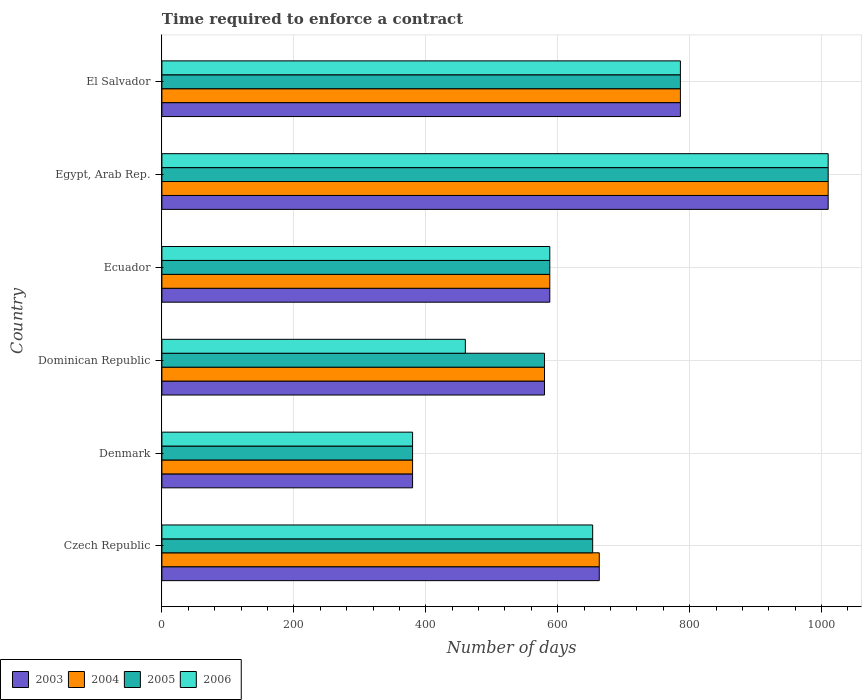Are the number of bars per tick equal to the number of legend labels?
Make the answer very short. Yes. What is the label of the 5th group of bars from the top?
Keep it short and to the point. Denmark. What is the number of days required to enforce a contract in 2005 in Dominican Republic?
Your answer should be very brief. 580. Across all countries, what is the maximum number of days required to enforce a contract in 2004?
Ensure brevity in your answer.  1010. Across all countries, what is the minimum number of days required to enforce a contract in 2006?
Your response must be concise. 380. In which country was the number of days required to enforce a contract in 2003 maximum?
Ensure brevity in your answer.  Egypt, Arab Rep. In which country was the number of days required to enforce a contract in 2004 minimum?
Make the answer very short. Denmark. What is the total number of days required to enforce a contract in 2005 in the graph?
Your response must be concise. 3997. What is the difference between the number of days required to enforce a contract in 2004 in Denmark and that in Egypt, Arab Rep.?
Give a very brief answer. -630. What is the difference between the number of days required to enforce a contract in 2006 in Dominican Republic and the number of days required to enforce a contract in 2005 in El Salvador?
Offer a very short reply. -326. What is the average number of days required to enforce a contract in 2004 per country?
Ensure brevity in your answer.  667.83. In how many countries, is the number of days required to enforce a contract in 2006 greater than 520 days?
Ensure brevity in your answer.  4. What is the ratio of the number of days required to enforce a contract in 2003 in Denmark to that in Egypt, Arab Rep.?
Ensure brevity in your answer.  0.38. Is the difference between the number of days required to enforce a contract in 2006 in Czech Republic and Egypt, Arab Rep. greater than the difference between the number of days required to enforce a contract in 2005 in Czech Republic and Egypt, Arab Rep.?
Keep it short and to the point. No. What is the difference between the highest and the second highest number of days required to enforce a contract in 2004?
Give a very brief answer. 224. What is the difference between the highest and the lowest number of days required to enforce a contract in 2004?
Provide a short and direct response. 630. Is it the case that in every country, the sum of the number of days required to enforce a contract in 2004 and number of days required to enforce a contract in 2005 is greater than the sum of number of days required to enforce a contract in 2006 and number of days required to enforce a contract in 2003?
Ensure brevity in your answer.  No. What does the 1st bar from the top in Dominican Republic represents?
Keep it short and to the point. 2006. What does the 1st bar from the bottom in El Salvador represents?
Offer a terse response. 2003. Are all the bars in the graph horizontal?
Give a very brief answer. Yes. What is the difference between two consecutive major ticks on the X-axis?
Your answer should be compact. 200. Are the values on the major ticks of X-axis written in scientific E-notation?
Your answer should be very brief. No. What is the title of the graph?
Your response must be concise. Time required to enforce a contract. What is the label or title of the X-axis?
Your response must be concise. Number of days. What is the Number of days in 2003 in Czech Republic?
Ensure brevity in your answer.  663. What is the Number of days of 2004 in Czech Republic?
Provide a succinct answer. 663. What is the Number of days in 2005 in Czech Republic?
Provide a short and direct response. 653. What is the Number of days in 2006 in Czech Republic?
Ensure brevity in your answer.  653. What is the Number of days of 2003 in Denmark?
Your answer should be very brief. 380. What is the Number of days of 2004 in Denmark?
Your response must be concise. 380. What is the Number of days of 2005 in Denmark?
Your answer should be compact. 380. What is the Number of days of 2006 in Denmark?
Keep it short and to the point. 380. What is the Number of days in 2003 in Dominican Republic?
Provide a succinct answer. 580. What is the Number of days in 2004 in Dominican Republic?
Keep it short and to the point. 580. What is the Number of days of 2005 in Dominican Republic?
Make the answer very short. 580. What is the Number of days in 2006 in Dominican Republic?
Ensure brevity in your answer.  460. What is the Number of days of 2003 in Ecuador?
Your answer should be very brief. 588. What is the Number of days of 2004 in Ecuador?
Your answer should be very brief. 588. What is the Number of days in 2005 in Ecuador?
Make the answer very short. 588. What is the Number of days in 2006 in Ecuador?
Make the answer very short. 588. What is the Number of days in 2003 in Egypt, Arab Rep.?
Make the answer very short. 1010. What is the Number of days in 2004 in Egypt, Arab Rep.?
Give a very brief answer. 1010. What is the Number of days of 2005 in Egypt, Arab Rep.?
Your response must be concise. 1010. What is the Number of days of 2006 in Egypt, Arab Rep.?
Offer a terse response. 1010. What is the Number of days of 2003 in El Salvador?
Provide a succinct answer. 786. What is the Number of days of 2004 in El Salvador?
Make the answer very short. 786. What is the Number of days in 2005 in El Salvador?
Your response must be concise. 786. What is the Number of days in 2006 in El Salvador?
Your response must be concise. 786. Across all countries, what is the maximum Number of days in 2003?
Give a very brief answer. 1010. Across all countries, what is the maximum Number of days of 2004?
Ensure brevity in your answer.  1010. Across all countries, what is the maximum Number of days in 2005?
Provide a short and direct response. 1010. Across all countries, what is the maximum Number of days of 2006?
Give a very brief answer. 1010. Across all countries, what is the minimum Number of days in 2003?
Give a very brief answer. 380. Across all countries, what is the minimum Number of days of 2004?
Ensure brevity in your answer.  380. Across all countries, what is the minimum Number of days of 2005?
Provide a succinct answer. 380. Across all countries, what is the minimum Number of days in 2006?
Provide a short and direct response. 380. What is the total Number of days of 2003 in the graph?
Your answer should be very brief. 4007. What is the total Number of days of 2004 in the graph?
Your answer should be compact. 4007. What is the total Number of days in 2005 in the graph?
Make the answer very short. 3997. What is the total Number of days of 2006 in the graph?
Offer a terse response. 3877. What is the difference between the Number of days of 2003 in Czech Republic and that in Denmark?
Provide a succinct answer. 283. What is the difference between the Number of days of 2004 in Czech Republic and that in Denmark?
Offer a terse response. 283. What is the difference between the Number of days of 2005 in Czech Republic and that in Denmark?
Your answer should be very brief. 273. What is the difference between the Number of days in 2006 in Czech Republic and that in Denmark?
Make the answer very short. 273. What is the difference between the Number of days of 2004 in Czech Republic and that in Dominican Republic?
Your response must be concise. 83. What is the difference between the Number of days in 2006 in Czech Republic and that in Dominican Republic?
Provide a short and direct response. 193. What is the difference between the Number of days of 2003 in Czech Republic and that in Egypt, Arab Rep.?
Give a very brief answer. -347. What is the difference between the Number of days in 2004 in Czech Republic and that in Egypt, Arab Rep.?
Your answer should be compact. -347. What is the difference between the Number of days in 2005 in Czech Republic and that in Egypt, Arab Rep.?
Your response must be concise. -357. What is the difference between the Number of days of 2006 in Czech Republic and that in Egypt, Arab Rep.?
Ensure brevity in your answer.  -357. What is the difference between the Number of days of 2003 in Czech Republic and that in El Salvador?
Give a very brief answer. -123. What is the difference between the Number of days of 2004 in Czech Republic and that in El Salvador?
Your answer should be very brief. -123. What is the difference between the Number of days of 2005 in Czech Republic and that in El Salvador?
Your answer should be compact. -133. What is the difference between the Number of days in 2006 in Czech Republic and that in El Salvador?
Keep it short and to the point. -133. What is the difference between the Number of days in 2003 in Denmark and that in Dominican Republic?
Give a very brief answer. -200. What is the difference between the Number of days in 2004 in Denmark and that in Dominican Republic?
Your response must be concise. -200. What is the difference between the Number of days of 2005 in Denmark and that in Dominican Republic?
Your response must be concise. -200. What is the difference between the Number of days of 2006 in Denmark and that in Dominican Republic?
Your answer should be very brief. -80. What is the difference between the Number of days of 2003 in Denmark and that in Ecuador?
Offer a very short reply. -208. What is the difference between the Number of days of 2004 in Denmark and that in Ecuador?
Offer a very short reply. -208. What is the difference between the Number of days in 2005 in Denmark and that in Ecuador?
Ensure brevity in your answer.  -208. What is the difference between the Number of days in 2006 in Denmark and that in Ecuador?
Provide a short and direct response. -208. What is the difference between the Number of days in 2003 in Denmark and that in Egypt, Arab Rep.?
Give a very brief answer. -630. What is the difference between the Number of days of 2004 in Denmark and that in Egypt, Arab Rep.?
Your answer should be very brief. -630. What is the difference between the Number of days of 2005 in Denmark and that in Egypt, Arab Rep.?
Provide a succinct answer. -630. What is the difference between the Number of days in 2006 in Denmark and that in Egypt, Arab Rep.?
Make the answer very short. -630. What is the difference between the Number of days of 2003 in Denmark and that in El Salvador?
Your response must be concise. -406. What is the difference between the Number of days in 2004 in Denmark and that in El Salvador?
Make the answer very short. -406. What is the difference between the Number of days in 2005 in Denmark and that in El Salvador?
Ensure brevity in your answer.  -406. What is the difference between the Number of days in 2006 in Denmark and that in El Salvador?
Offer a very short reply. -406. What is the difference between the Number of days of 2003 in Dominican Republic and that in Ecuador?
Your answer should be compact. -8. What is the difference between the Number of days of 2006 in Dominican Republic and that in Ecuador?
Offer a very short reply. -128. What is the difference between the Number of days of 2003 in Dominican Republic and that in Egypt, Arab Rep.?
Your answer should be very brief. -430. What is the difference between the Number of days in 2004 in Dominican Republic and that in Egypt, Arab Rep.?
Give a very brief answer. -430. What is the difference between the Number of days in 2005 in Dominican Republic and that in Egypt, Arab Rep.?
Provide a short and direct response. -430. What is the difference between the Number of days in 2006 in Dominican Republic and that in Egypt, Arab Rep.?
Keep it short and to the point. -550. What is the difference between the Number of days of 2003 in Dominican Republic and that in El Salvador?
Provide a short and direct response. -206. What is the difference between the Number of days in 2004 in Dominican Republic and that in El Salvador?
Your answer should be compact. -206. What is the difference between the Number of days in 2005 in Dominican Republic and that in El Salvador?
Your response must be concise. -206. What is the difference between the Number of days of 2006 in Dominican Republic and that in El Salvador?
Your response must be concise. -326. What is the difference between the Number of days in 2003 in Ecuador and that in Egypt, Arab Rep.?
Offer a terse response. -422. What is the difference between the Number of days in 2004 in Ecuador and that in Egypt, Arab Rep.?
Your response must be concise. -422. What is the difference between the Number of days in 2005 in Ecuador and that in Egypt, Arab Rep.?
Your answer should be very brief. -422. What is the difference between the Number of days of 2006 in Ecuador and that in Egypt, Arab Rep.?
Provide a succinct answer. -422. What is the difference between the Number of days of 2003 in Ecuador and that in El Salvador?
Ensure brevity in your answer.  -198. What is the difference between the Number of days in 2004 in Ecuador and that in El Salvador?
Keep it short and to the point. -198. What is the difference between the Number of days of 2005 in Ecuador and that in El Salvador?
Give a very brief answer. -198. What is the difference between the Number of days in 2006 in Ecuador and that in El Salvador?
Provide a succinct answer. -198. What is the difference between the Number of days of 2003 in Egypt, Arab Rep. and that in El Salvador?
Offer a terse response. 224. What is the difference between the Number of days in 2004 in Egypt, Arab Rep. and that in El Salvador?
Ensure brevity in your answer.  224. What is the difference between the Number of days of 2005 in Egypt, Arab Rep. and that in El Salvador?
Keep it short and to the point. 224. What is the difference between the Number of days of 2006 in Egypt, Arab Rep. and that in El Salvador?
Provide a short and direct response. 224. What is the difference between the Number of days of 2003 in Czech Republic and the Number of days of 2004 in Denmark?
Provide a short and direct response. 283. What is the difference between the Number of days in 2003 in Czech Republic and the Number of days in 2005 in Denmark?
Make the answer very short. 283. What is the difference between the Number of days of 2003 in Czech Republic and the Number of days of 2006 in Denmark?
Keep it short and to the point. 283. What is the difference between the Number of days in 2004 in Czech Republic and the Number of days in 2005 in Denmark?
Make the answer very short. 283. What is the difference between the Number of days of 2004 in Czech Republic and the Number of days of 2006 in Denmark?
Your response must be concise. 283. What is the difference between the Number of days in 2005 in Czech Republic and the Number of days in 2006 in Denmark?
Your response must be concise. 273. What is the difference between the Number of days of 2003 in Czech Republic and the Number of days of 2004 in Dominican Republic?
Give a very brief answer. 83. What is the difference between the Number of days in 2003 in Czech Republic and the Number of days in 2006 in Dominican Republic?
Offer a very short reply. 203. What is the difference between the Number of days of 2004 in Czech Republic and the Number of days of 2006 in Dominican Republic?
Offer a terse response. 203. What is the difference between the Number of days in 2005 in Czech Republic and the Number of days in 2006 in Dominican Republic?
Give a very brief answer. 193. What is the difference between the Number of days in 2003 in Czech Republic and the Number of days in 2004 in Ecuador?
Ensure brevity in your answer.  75. What is the difference between the Number of days of 2003 in Czech Republic and the Number of days of 2006 in Ecuador?
Make the answer very short. 75. What is the difference between the Number of days in 2005 in Czech Republic and the Number of days in 2006 in Ecuador?
Provide a succinct answer. 65. What is the difference between the Number of days of 2003 in Czech Republic and the Number of days of 2004 in Egypt, Arab Rep.?
Offer a terse response. -347. What is the difference between the Number of days in 2003 in Czech Republic and the Number of days in 2005 in Egypt, Arab Rep.?
Provide a short and direct response. -347. What is the difference between the Number of days in 2003 in Czech Republic and the Number of days in 2006 in Egypt, Arab Rep.?
Provide a succinct answer. -347. What is the difference between the Number of days of 2004 in Czech Republic and the Number of days of 2005 in Egypt, Arab Rep.?
Keep it short and to the point. -347. What is the difference between the Number of days of 2004 in Czech Republic and the Number of days of 2006 in Egypt, Arab Rep.?
Keep it short and to the point. -347. What is the difference between the Number of days of 2005 in Czech Republic and the Number of days of 2006 in Egypt, Arab Rep.?
Offer a very short reply. -357. What is the difference between the Number of days of 2003 in Czech Republic and the Number of days of 2004 in El Salvador?
Your answer should be compact. -123. What is the difference between the Number of days in 2003 in Czech Republic and the Number of days in 2005 in El Salvador?
Your answer should be very brief. -123. What is the difference between the Number of days of 2003 in Czech Republic and the Number of days of 2006 in El Salvador?
Ensure brevity in your answer.  -123. What is the difference between the Number of days of 2004 in Czech Republic and the Number of days of 2005 in El Salvador?
Provide a short and direct response. -123. What is the difference between the Number of days of 2004 in Czech Republic and the Number of days of 2006 in El Salvador?
Make the answer very short. -123. What is the difference between the Number of days in 2005 in Czech Republic and the Number of days in 2006 in El Salvador?
Provide a succinct answer. -133. What is the difference between the Number of days of 2003 in Denmark and the Number of days of 2004 in Dominican Republic?
Make the answer very short. -200. What is the difference between the Number of days in 2003 in Denmark and the Number of days in 2005 in Dominican Republic?
Provide a succinct answer. -200. What is the difference between the Number of days in 2003 in Denmark and the Number of days in 2006 in Dominican Republic?
Ensure brevity in your answer.  -80. What is the difference between the Number of days in 2004 in Denmark and the Number of days in 2005 in Dominican Republic?
Offer a terse response. -200. What is the difference between the Number of days in 2004 in Denmark and the Number of days in 2006 in Dominican Republic?
Provide a short and direct response. -80. What is the difference between the Number of days of 2005 in Denmark and the Number of days of 2006 in Dominican Republic?
Ensure brevity in your answer.  -80. What is the difference between the Number of days of 2003 in Denmark and the Number of days of 2004 in Ecuador?
Keep it short and to the point. -208. What is the difference between the Number of days in 2003 in Denmark and the Number of days in 2005 in Ecuador?
Give a very brief answer. -208. What is the difference between the Number of days in 2003 in Denmark and the Number of days in 2006 in Ecuador?
Give a very brief answer. -208. What is the difference between the Number of days in 2004 in Denmark and the Number of days in 2005 in Ecuador?
Keep it short and to the point. -208. What is the difference between the Number of days of 2004 in Denmark and the Number of days of 2006 in Ecuador?
Provide a succinct answer. -208. What is the difference between the Number of days of 2005 in Denmark and the Number of days of 2006 in Ecuador?
Your response must be concise. -208. What is the difference between the Number of days of 2003 in Denmark and the Number of days of 2004 in Egypt, Arab Rep.?
Your response must be concise. -630. What is the difference between the Number of days in 2003 in Denmark and the Number of days in 2005 in Egypt, Arab Rep.?
Make the answer very short. -630. What is the difference between the Number of days of 2003 in Denmark and the Number of days of 2006 in Egypt, Arab Rep.?
Ensure brevity in your answer.  -630. What is the difference between the Number of days of 2004 in Denmark and the Number of days of 2005 in Egypt, Arab Rep.?
Give a very brief answer. -630. What is the difference between the Number of days of 2004 in Denmark and the Number of days of 2006 in Egypt, Arab Rep.?
Provide a short and direct response. -630. What is the difference between the Number of days in 2005 in Denmark and the Number of days in 2006 in Egypt, Arab Rep.?
Make the answer very short. -630. What is the difference between the Number of days of 2003 in Denmark and the Number of days of 2004 in El Salvador?
Offer a very short reply. -406. What is the difference between the Number of days in 2003 in Denmark and the Number of days in 2005 in El Salvador?
Offer a very short reply. -406. What is the difference between the Number of days in 2003 in Denmark and the Number of days in 2006 in El Salvador?
Make the answer very short. -406. What is the difference between the Number of days of 2004 in Denmark and the Number of days of 2005 in El Salvador?
Give a very brief answer. -406. What is the difference between the Number of days of 2004 in Denmark and the Number of days of 2006 in El Salvador?
Your answer should be compact. -406. What is the difference between the Number of days of 2005 in Denmark and the Number of days of 2006 in El Salvador?
Offer a very short reply. -406. What is the difference between the Number of days in 2003 in Dominican Republic and the Number of days in 2004 in Ecuador?
Make the answer very short. -8. What is the difference between the Number of days in 2003 in Dominican Republic and the Number of days in 2005 in Ecuador?
Provide a succinct answer. -8. What is the difference between the Number of days in 2003 in Dominican Republic and the Number of days in 2006 in Ecuador?
Your answer should be very brief. -8. What is the difference between the Number of days of 2005 in Dominican Republic and the Number of days of 2006 in Ecuador?
Your answer should be very brief. -8. What is the difference between the Number of days in 2003 in Dominican Republic and the Number of days in 2004 in Egypt, Arab Rep.?
Keep it short and to the point. -430. What is the difference between the Number of days of 2003 in Dominican Republic and the Number of days of 2005 in Egypt, Arab Rep.?
Your response must be concise. -430. What is the difference between the Number of days of 2003 in Dominican Republic and the Number of days of 2006 in Egypt, Arab Rep.?
Your response must be concise. -430. What is the difference between the Number of days in 2004 in Dominican Republic and the Number of days in 2005 in Egypt, Arab Rep.?
Provide a short and direct response. -430. What is the difference between the Number of days in 2004 in Dominican Republic and the Number of days in 2006 in Egypt, Arab Rep.?
Offer a very short reply. -430. What is the difference between the Number of days of 2005 in Dominican Republic and the Number of days of 2006 in Egypt, Arab Rep.?
Provide a short and direct response. -430. What is the difference between the Number of days in 2003 in Dominican Republic and the Number of days in 2004 in El Salvador?
Keep it short and to the point. -206. What is the difference between the Number of days in 2003 in Dominican Republic and the Number of days in 2005 in El Salvador?
Your response must be concise. -206. What is the difference between the Number of days in 2003 in Dominican Republic and the Number of days in 2006 in El Salvador?
Make the answer very short. -206. What is the difference between the Number of days of 2004 in Dominican Republic and the Number of days of 2005 in El Salvador?
Make the answer very short. -206. What is the difference between the Number of days of 2004 in Dominican Republic and the Number of days of 2006 in El Salvador?
Give a very brief answer. -206. What is the difference between the Number of days in 2005 in Dominican Republic and the Number of days in 2006 in El Salvador?
Your response must be concise. -206. What is the difference between the Number of days in 2003 in Ecuador and the Number of days in 2004 in Egypt, Arab Rep.?
Your answer should be compact. -422. What is the difference between the Number of days of 2003 in Ecuador and the Number of days of 2005 in Egypt, Arab Rep.?
Your response must be concise. -422. What is the difference between the Number of days of 2003 in Ecuador and the Number of days of 2006 in Egypt, Arab Rep.?
Ensure brevity in your answer.  -422. What is the difference between the Number of days of 2004 in Ecuador and the Number of days of 2005 in Egypt, Arab Rep.?
Make the answer very short. -422. What is the difference between the Number of days in 2004 in Ecuador and the Number of days in 2006 in Egypt, Arab Rep.?
Keep it short and to the point. -422. What is the difference between the Number of days in 2005 in Ecuador and the Number of days in 2006 in Egypt, Arab Rep.?
Provide a short and direct response. -422. What is the difference between the Number of days in 2003 in Ecuador and the Number of days in 2004 in El Salvador?
Make the answer very short. -198. What is the difference between the Number of days in 2003 in Ecuador and the Number of days in 2005 in El Salvador?
Your answer should be very brief. -198. What is the difference between the Number of days of 2003 in Ecuador and the Number of days of 2006 in El Salvador?
Offer a very short reply. -198. What is the difference between the Number of days of 2004 in Ecuador and the Number of days of 2005 in El Salvador?
Ensure brevity in your answer.  -198. What is the difference between the Number of days of 2004 in Ecuador and the Number of days of 2006 in El Salvador?
Your answer should be very brief. -198. What is the difference between the Number of days in 2005 in Ecuador and the Number of days in 2006 in El Salvador?
Your answer should be very brief. -198. What is the difference between the Number of days of 2003 in Egypt, Arab Rep. and the Number of days of 2004 in El Salvador?
Provide a succinct answer. 224. What is the difference between the Number of days of 2003 in Egypt, Arab Rep. and the Number of days of 2005 in El Salvador?
Your response must be concise. 224. What is the difference between the Number of days of 2003 in Egypt, Arab Rep. and the Number of days of 2006 in El Salvador?
Ensure brevity in your answer.  224. What is the difference between the Number of days in 2004 in Egypt, Arab Rep. and the Number of days in 2005 in El Salvador?
Your response must be concise. 224. What is the difference between the Number of days of 2004 in Egypt, Arab Rep. and the Number of days of 2006 in El Salvador?
Ensure brevity in your answer.  224. What is the difference between the Number of days of 2005 in Egypt, Arab Rep. and the Number of days of 2006 in El Salvador?
Give a very brief answer. 224. What is the average Number of days in 2003 per country?
Your answer should be compact. 667.83. What is the average Number of days in 2004 per country?
Make the answer very short. 667.83. What is the average Number of days in 2005 per country?
Provide a short and direct response. 666.17. What is the average Number of days in 2006 per country?
Your answer should be very brief. 646.17. What is the difference between the Number of days in 2003 and Number of days in 2004 in Czech Republic?
Offer a terse response. 0. What is the difference between the Number of days in 2003 and Number of days in 2005 in Czech Republic?
Your answer should be very brief. 10. What is the difference between the Number of days in 2004 and Number of days in 2006 in Czech Republic?
Give a very brief answer. 10. What is the difference between the Number of days of 2005 and Number of days of 2006 in Czech Republic?
Your answer should be compact. 0. What is the difference between the Number of days of 2003 and Number of days of 2004 in Denmark?
Your response must be concise. 0. What is the difference between the Number of days in 2004 and Number of days in 2005 in Denmark?
Keep it short and to the point. 0. What is the difference between the Number of days of 2004 and Number of days of 2006 in Denmark?
Give a very brief answer. 0. What is the difference between the Number of days of 2003 and Number of days of 2004 in Dominican Republic?
Keep it short and to the point. 0. What is the difference between the Number of days of 2003 and Number of days of 2005 in Dominican Republic?
Ensure brevity in your answer.  0. What is the difference between the Number of days of 2003 and Number of days of 2006 in Dominican Republic?
Give a very brief answer. 120. What is the difference between the Number of days in 2004 and Number of days in 2005 in Dominican Republic?
Your response must be concise. 0. What is the difference between the Number of days in 2004 and Number of days in 2006 in Dominican Republic?
Your answer should be compact. 120. What is the difference between the Number of days of 2005 and Number of days of 2006 in Dominican Republic?
Offer a very short reply. 120. What is the difference between the Number of days of 2003 and Number of days of 2006 in Ecuador?
Your answer should be very brief. 0. What is the difference between the Number of days in 2004 and Number of days in 2005 in Ecuador?
Your response must be concise. 0. What is the difference between the Number of days of 2005 and Number of days of 2006 in Ecuador?
Provide a succinct answer. 0. What is the difference between the Number of days of 2004 and Number of days of 2005 in Egypt, Arab Rep.?
Offer a terse response. 0. What is the difference between the Number of days of 2003 and Number of days of 2005 in El Salvador?
Provide a succinct answer. 0. What is the difference between the Number of days of 2003 and Number of days of 2006 in El Salvador?
Provide a succinct answer. 0. What is the difference between the Number of days of 2004 and Number of days of 2006 in El Salvador?
Keep it short and to the point. 0. What is the ratio of the Number of days of 2003 in Czech Republic to that in Denmark?
Keep it short and to the point. 1.74. What is the ratio of the Number of days of 2004 in Czech Republic to that in Denmark?
Make the answer very short. 1.74. What is the ratio of the Number of days of 2005 in Czech Republic to that in Denmark?
Provide a succinct answer. 1.72. What is the ratio of the Number of days of 2006 in Czech Republic to that in Denmark?
Give a very brief answer. 1.72. What is the ratio of the Number of days in 2003 in Czech Republic to that in Dominican Republic?
Provide a succinct answer. 1.14. What is the ratio of the Number of days in 2004 in Czech Republic to that in Dominican Republic?
Offer a terse response. 1.14. What is the ratio of the Number of days in 2005 in Czech Republic to that in Dominican Republic?
Give a very brief answer. 1.13. What is the ratio of the Number of days of 2006 in Czech Republic to that in Dominican Republic?
Provide a short and direct response. 1.42. What is the ratio of the Number of days in 2003 in Czech Republic to that in Ecuador?
Offer a very short reply. 1.13. What is the ratio of the Number of days of 2004 in Czech Republic to that in Ecuador?
Keep it short and to the point. 1.13. What is the ratio of the Number of days of 2005 in Czech Republic to that in Ecuador?
Give a very brief answer. 1.11. What is the ratio of the Number of days of 2006 in Czech Republic to that in Ecuador?
Make the answer very short. 1.11. What is the ratio of the Number of days of 2003 in Czech Republic to that in Egypt, Arab Rep.?
Your answer should be compact. 0.66. What is the ratio of the Number of days in 2004 in Czech Republic to that in Egypt, Arab Rep.?
Your response must be concise. 0.66. What is the ratio of the Number of days of 2005 in Czech Republic to that in Egypt, Arab Rep.?
Offer a very short reply. 0.65. What is the ratio of the Number of days of 2006 in Czech Republic to that in Egypt, Arab Rep.?
Give a very brief answer. 0.65. What is the ratio of the Number of days of 2003 in Czech Republic to that in El Salvador?
Offer a very short reply. 0.84. What is the ratio of the Number of days in 2004 in Czech Republic to that in El Salvador?
Your response must be concise. 0.84. What is the ratio of the Number of days in 2005 in Czech Republic to that in El Salvador?
Offer a terse response. 0.83. What is the ratio of the Number of days in 2006 in Czech Republic to that in El Salvador?
Offer a very short reply. 0.83. What is the ratio of the Number of days in 2003 in Denmark to that in Dominican Republic?
Give a very brief answer. 0.66. What is the ratio of the Number of days in 2004 in Denmark to that in Dominican Republic?
Give a very brief answer. 0.66. What is the ratio of the Number of days of 2005 in Denmark to that in Dominican Republic?
Keep it short and to the point. 0.66. What is the ratio of the Number of days of 2006 in Denmark to that in Dominican Republic?
Your answer should be compact. 0.83. What is the ratio of the Number of days in 2003 in Denmark to that in Ecuador?
Your answer should be compact. 0.65. What is the ratio of the Number of days in 2004 in Denmark to that in Ecuador?
Your answer should be very brief. 0.65. What is the ratio of the Number of days of 2005 in Denmark to that in Ecuador?
Make the answer very short. 0.65. What is the ratio of the Number of days of 2006 in Denmark to that in Ecuador?
Your answer should be compact. 0.65. What is the ratio of the Number of days in 2003 in Denmark to that in Egypt, Arab Rep.?
Offer a terse response. 0.38. What is the ratio of the Number of days of 2004 in Denmark to that in Egypt, Arab Rep.?
Your response must be concise. 0.38. What is the ratio of the Number of days of 2005 in Denmark to that in Egypt, Arab Rep.?
Offer a very short reply. 0.38. What is the ratio of the Number of days of 2006 in Denmark to that in Egypt, Arab Rep.?
Keep it short and to the point. 0.38. What is the ratio of the Number of days in 2003 in Denmark to that in El Salvador?
Offer a terse response. 0.48. What is the ratio of the Number of days of 2004 in Denmark to that in El Salvador?
Your response must be concise. 0.48. What is the ratio of the Number of days in 2005 in Denmark to that in El Salvador?
Offer a terse response. 0.48. What is the ratio of the Number of days of 2006 in Denmark to that in El Salvador?
Your response must be concise. 0.48. What is the ratio of the Number of days of 2003 in Dominican Republic to that in Ecuador?
Give a very brief answer. 0.99. What is the ratio of the Number of days of 2004 in Dominican Republic to that in Ecuador?
Offer a very short reply. 0.99. What is the ratio of the Number of days of 2005 in Dominican Republic to that in Ecuador?
Offer a terse response. 0.99. What is the ratio of the Number of days of 2006 in Dominican Republic to that in Ecuador?
Offer a terse response. 0.78. What is the ratio of the Number of days in 2003 in Dominican Republic to that in Egypt, Arab Rep.?
Ensure brevity in your answer.  0.57. What is the ratio of the Number of days of 2004 in Dominican Republic to that in Egypt, Arab Rep.?
Offer a terse response. 0.57. What is the ratio of the Number of days of 2005 in Dominican Republic to that in Egypt, Arab Rep.?
Your answer should be compact. 0.57. What is the ratio of the Number of days of 2006 in Dominican Republic to that in Egypt, Arab Rep.?
Provide a succinct answer. 0.46. What is the ratio of the Number of days in 2003 in Dominican Republic to that in El Salvador?
Your response must be concise. 0.74. What is the ratio of the Number of days of 2004 in Dominican Republic to that in El Salvador?
Offer a terse response. 0.74. What is the ratio of the Number of days in 2005 in Dominican Republic to that in El Salvador?
Ensure brevity in your answer.  0.74. What is the ratio of the Number of days of 2006 in Dominican Republic to that in El Salvador?
Your response must be concise. 0.59. What is the ratio of the Number of days of 2003 in Ecuador to that in Egypt, Arab Rep.?
Offer a very short reply. 0.58. What is the ratio of the Number of days of 2004 in Ecuador to that in Egypt, Arab Rep.?
Ensure brevity in your answer.  0.58. What is the ratio of the Number of days in 2005 in Ecuador to that in Egypt, Arab Rep.?
Make the answer very short. 0.58. What is the ratio of the Number of days of 2006 in Ecuador to that in Egypt, Arab Rep.?
Make the answer very short. 0.58. What is the ratio of the Number of days of 2003 in Ecuador to that in El Salvador?
Provide a succinct answer. 0.75. What is the ratio of the Number of days in 2004 in Ecuador to that in El Salvador?
Ensure brevity in your answer.  0.75. What is the ratio of the Number of days in 2005 in Ecuador to that in El Salvador?
Your answer should be compact. 0.75. What is the ratio of the Number of days of 2006 in Ecuador to that in El Salvador?
Your answer should be compact. 0.75. What is the ratio of the Number of days of 2003 in Egypt, Arab Rep. to that in El Salvador?
Your response must be concise. 1.28. What is the ratio of the Number of days in 2004 in Egypt, Arab Rep. to that in El Salvador?
Your answer should be very brief. 1.28. What is the ratio of the Number of days in 2005 in Egypt, Arab Rep. to that in El Salvador?
Your response must be concise. 1.28. What is the ratio of the Number of days of 2006 in Egypt, Arab Rep. to that in El Salvador?
Make the answer very short. 1.28. What is the difference between the highest and the second highest Number of days of 2003?
Make the answer very short. 224. What is the difference between the highest and the second highest Number of days of 2004?
Your answer should be very brief. 224. What is the difference between the highest and the second highest Number of days of 2005?
Give a very brief answer. 224. What is the difference between the highest and the second highest Number of days of 2006?
Provide a short and direct response. 224. What is the difference between the highest and the lowest Number of days of 2003?
Provide a short and direct response. 630. What is the difference between the highest and the lowest Number of days of 2004?
Your answer should be very brief. 630. What is the difference between the highest and the lowest Number of days of 2005?
Keep it short and to the point. 630. What is the difference between the highest and the lowest Number of days in 2006?
Give a very brief answer. 630. 